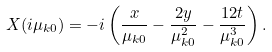<formula> <loc_0><loc_0><loc_500><loc_500>X ( i \mu _ { k 0 } ) = - i \left ( \frac { x } { \mu _ { k 0 } } - \frac { 2 y } { \mu ^ { 2 } _ { k 0 } } - \frac { 1 2 t } { \mu ^ { 3 } _ { k 0 } } \right ) .</formula> 